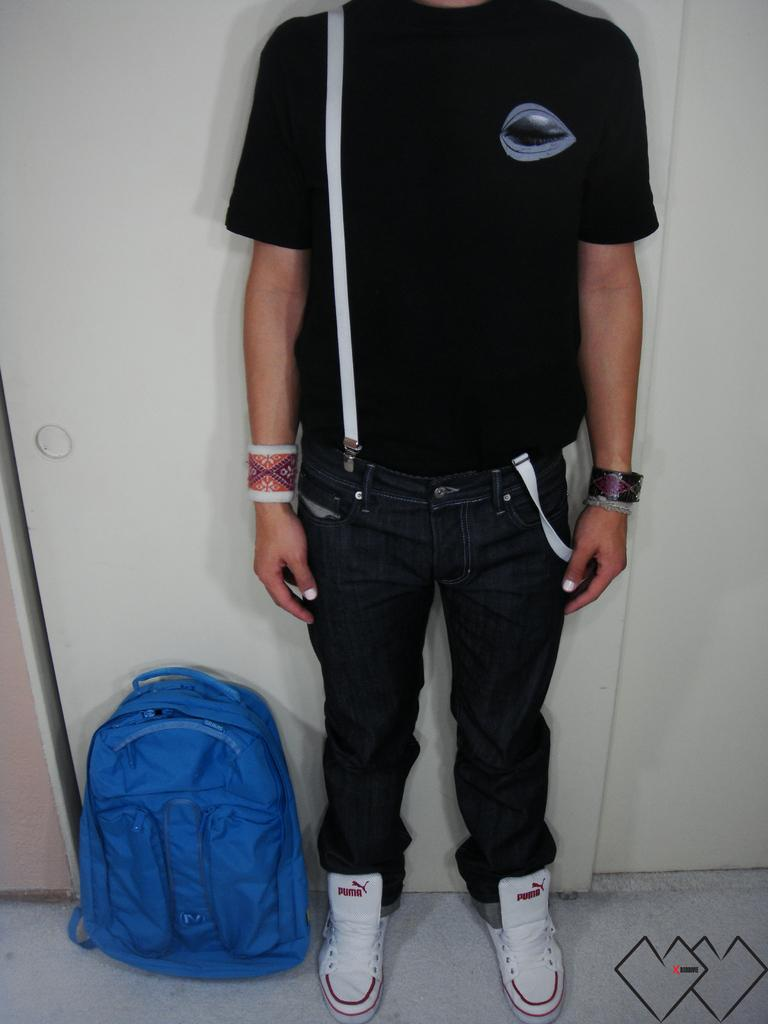Who is present in the image? There is a man in the image. What is covering the man's head? The man's head is covered. What color is the man's shirt? The man is wearing a black shirt. What color are the man's jeans? The man is wearing black jeans. What color are the man's shoes? The man is wearing white shoes. What item is beside the man? There is a blue backpack beside the man. What type of stem can be seen growing from the man's shoes in the image? There is no stem growing from the man's shoes in the image. What type of paper is the man holding in the image? There is no paper present in the image. 